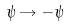Convert formula to latex. <formula><loc_0><loc_0><loc_500><loc_500>\psi \rightarrow - \psi \,</formula> 